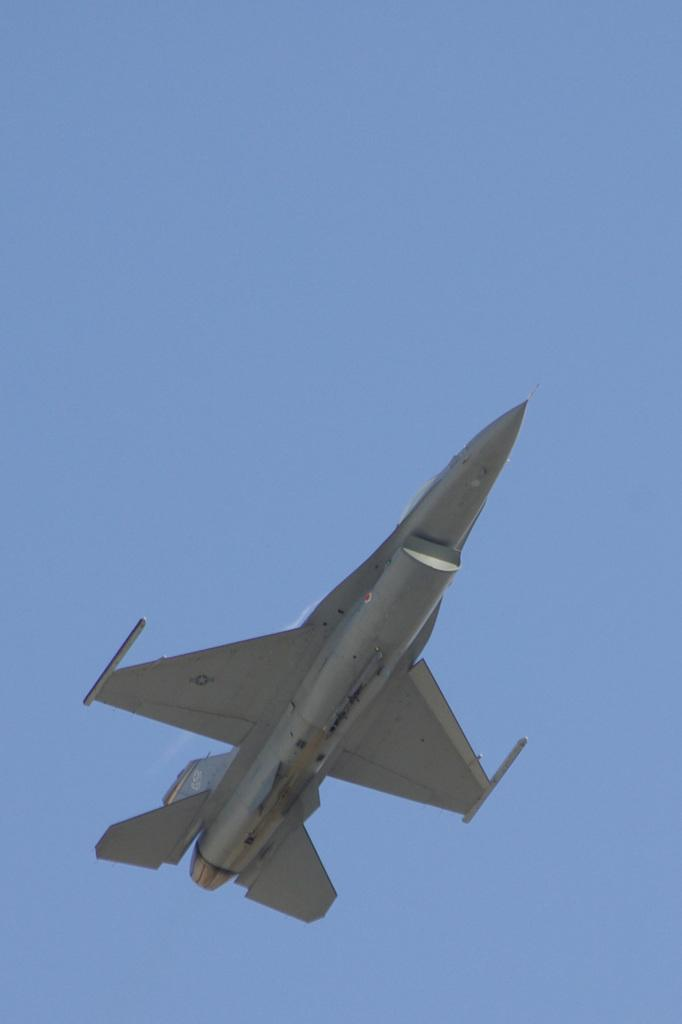What is the main subject of the image? The main subject of the image is an aircraft. What is the aircraft doing in the image? The aircraft is flying in the image. What can be seen in the background of the image? The sky is visible in the background of the image. Who is guiding the aircraft in the image? There is no person guiding the aircraft in the image; it is flying on its own. Is there a boy visible in the image? There is no boy present in the image. 